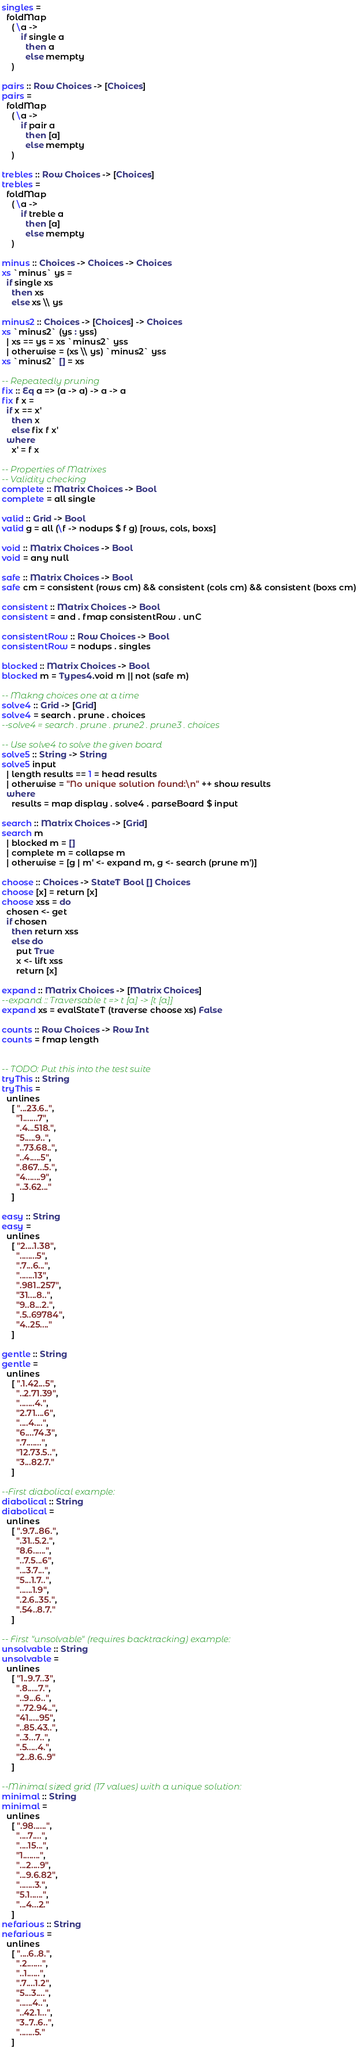Convert code to text. <code><loc_0><loc_0><loc_500><loc_500><_Haskell_>singles =
  foldMap
    ( \a ->
        if single a
          then a
          else mempty
    )

pairs :: Row Choices -> [Choices]
pairs =
  foldMap
    ( \a ->
        if pair a
          then [a]
          else mempty
    )

trebles :: Row Choices -> [Choices]
trebles =
  foldMap
    ( \a ->
        if treble a
          then [a]
          else mempty
    )

minus :: Choices -> Choices -> Choices
xs `minus` ys =
  if single xs
    then xs
    else xs \\ ys

minus2 :: Choices -> [Choices] -> Choices
xs `minus2` (ys : yss)
  | xs == ys = xs `minus2` yss
  | otherwise = (xs \\ ys) `minus2` yss
xs `minus2` [] = xs

-- Repeatedly pruning
fix :: Eq a => (a -> a) -> a -> a
fix f x =
  if x == x'
    then x
    else fix f x'
  where
    x' = f x

-- Properties of Matrixes
-- Validity checking
complete :: Matrix Choices -> Bool
complete = all single

valid :: Grid -> Bool
valid g = all (\f -> nodups $ f g) [rows, cols, boxs]

void :: Matrix Choices -> Bool
void = any null

safe :: Matrix Choices -> Bool
safe cm = consistent (rows cm) && consistent (cols cm) && consistent (boxs cm)

consistent :: Matrix Choices -> Bool
consistent = and . fmap consistentRow . unC

consistentRow :: Row Choices -> Bool
consistentRow = nodups . singles

blocked :: Matrix Choices -> Bool
blocked m = Types4.void m || not (safe m)

-- Makng choices one at a time
solve4 :: Grid -> [Grid]
solve4 = search . prune . choices
--solve4 = search . prune . prune2 . prune3 . choices

-- Use solve4 to solve the given board
solve5 :: String -> String
solve5 input
  | length results == 1 = head results
  | otherwise = "No unique solution found:\n" ++ show results
  where
    results = map display . solve4 . parseBoard $ input

search :: Matrix Choices -> [Grid]
search m
  | blocked m = []
  | complete m = collapse m
  | otherwise = [g | m' <- expand m, g <- search (prune m')]

choose :: Choices -> StateT Bool [] Choices
choose [x] = return [x]
choose xss = do
  chosen <- get
  if chosen
    then return xss
    else do
      put True
      x <- lift xss
      return [x]

expand :: Matrix Choices -> [Matrix Choices]
--expand :: Traversable t => t [a] -> [t [a]]
expand xs = evalStateT (traverse choose xs) False

counts :: Row Choices -> Row Int
counts = fmap length


-- TODO: Put this into the test suite
tryThis :: String
tryThis =
  unlines
    [ "...23.6..",
      "1.......7",
      ".4...518.",
      "5.....9..",
      "..73.68..",
      "..4.....5",
      ".867...5.",
      "4.......9",
      "..3.62..."
    ]

easy :: String
easy =
  unlines
    [ "2....1.38",
      "........5",
      ".7...6...",
      ".......13",
      ".981..257",
      "31....8..",
      "9..8...2.",
      ".5..69784",
      "4..25...."
    ]

gentle :: String
gentle =
  unlines
    [ ".1.42...5",
      "..2.71.39",
      ".......4.",
      "2.71....6",
      "....4....",
      "6....74.3",
      ".7.......",
      "12.73.5..",
      "3...82.7."
    ]

--First diabolical example:
diabolical :: String
diabolical =
  unlines
    [ ".9.7..86.",
      ".31..5.2.",
      "8.6......",
      "..7.5...6",
      "...3.7...",
      "5...1.7..",
      "......1.9",
      ".2.6..35.",
      ".54..8.7."
    ]

-- First "unsolvable" (requires backtracking) example:
unsolvable :: String
unsolvable =
  unlines
    [ "1..9.7..3",
      ".8.....7.",
      "..9...6..",
      "..72.94..",
      "41.....95",
      "..85.43..",
      "..3...7..",
      ".5.....4.",
      "2..8.6..9"
    ]

--Minimal sized grid (17 values) with a unique solution:
minimal :: String
minimal =
  unlines
    [ ".98......",
      "....7....",
      "....15...",
      "1........",
      "...2....9",
      "...9.6.82",
      ".......3.",
      "5.1......",
      "...4...2."
    ]
nefarious :: String
nefarious =
  unlines
    [ "....6..8.",
      ".2.......",
      "..1......",
      ".7....1.2",
      "5...3....",
      "......4..",
      "..42.1...",
      "3..7..6..",
      ".......5."
    ]
</code> 